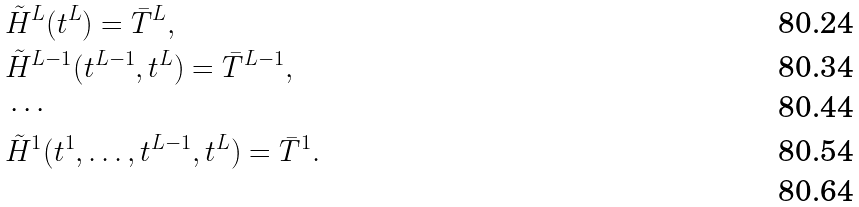Convert formula to latex. <formula><loc_0><loc_0><loc_500><loc_500>& \tilde { H } ^ { L } ( t ^ { L } ) = \bar { T } ^ { L } , \\ & \tilde { H } ^ { L - 1 } ( t ^ { L - 1 } , t ^ { L } ) = \bar { T } ^ { L - 1 } , \\ & \cdots \\ & \tilde { H } ^ { 1 } ( t ^ { 1 } , \dots , t ^ { L - 1 } , t ^ { L } ) = \bar { T } ^ { 1 } . \\</formula> 